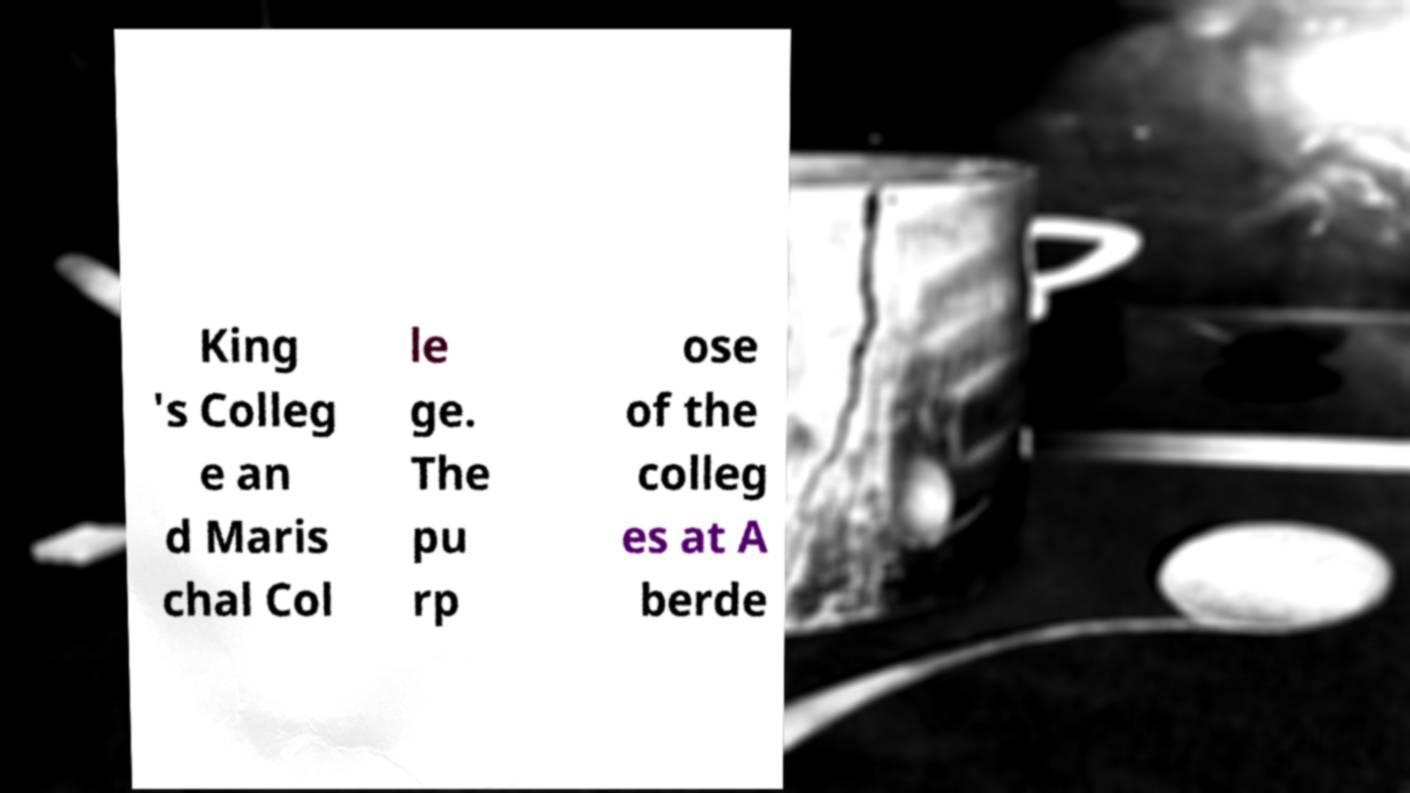I need the written content from this picture converted into text. Can you do that? King 's Colleg e an d Maris chal Col le ge. The pu rp ose of the colleg es at A berde 